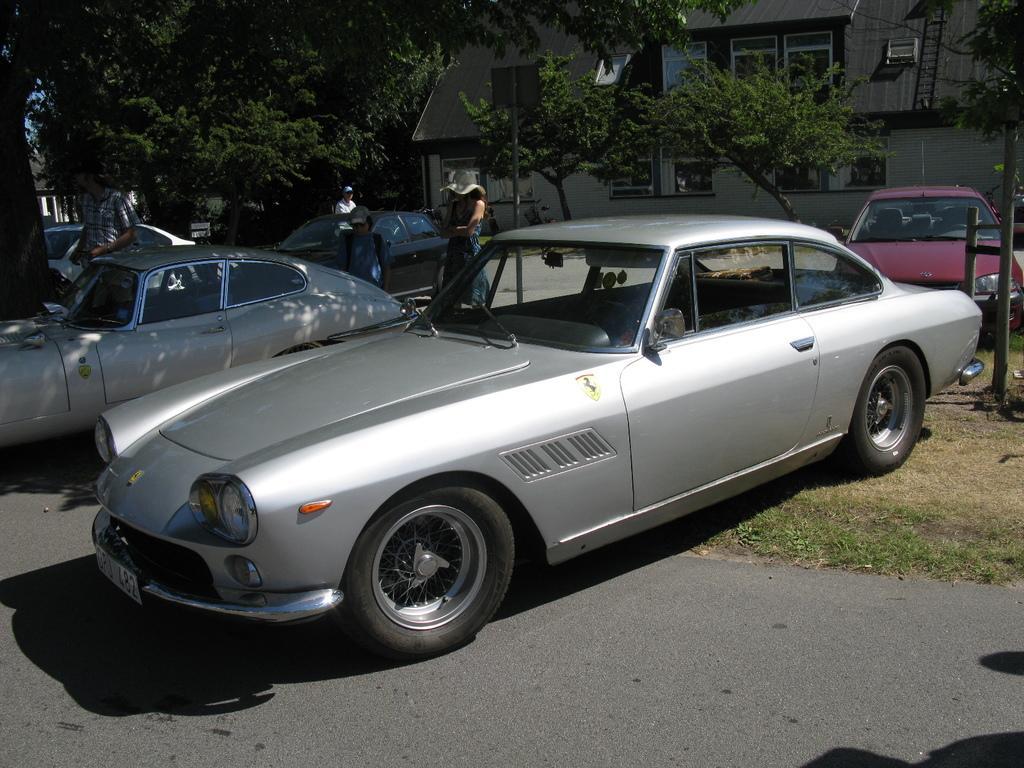In one or two sentences, can you explain what this image depicts? This image is taken outdoors. At the bottom of the image there is a road and there is a ground with grass on it. In the background there are a few trees and there is a house with walls, windows, a door and a roof. There is a ladder. In the middle of the image many cars are parked on the ground and a few people are standing on the ground. On the right side of the image there is a pole. 